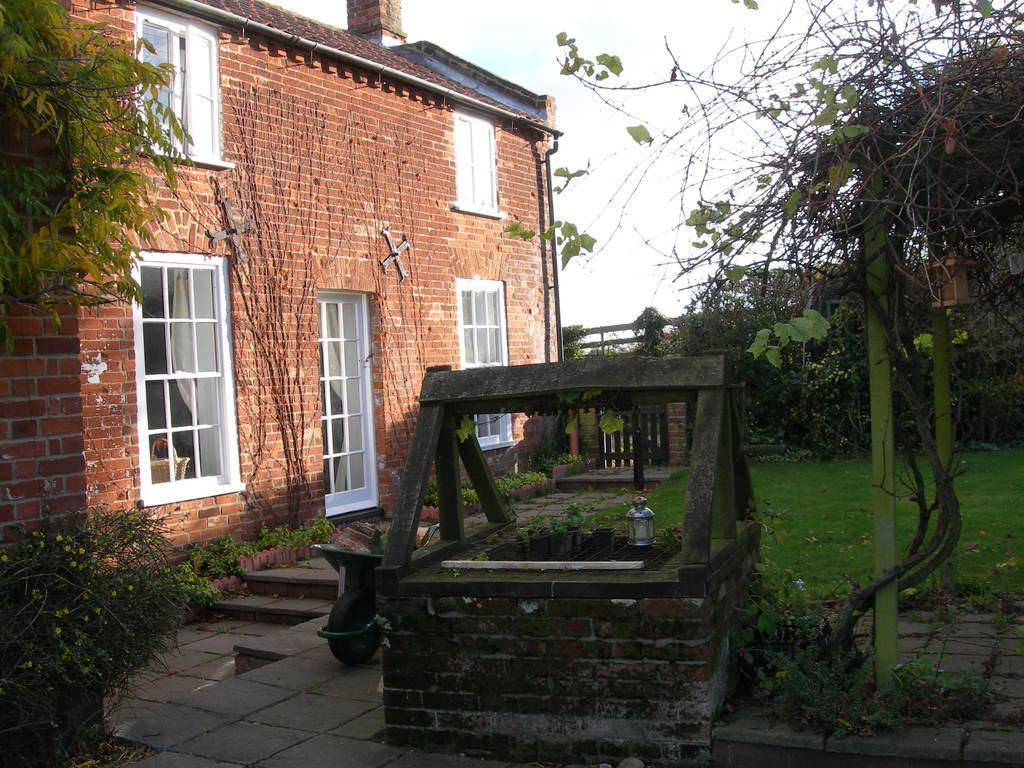Describe this image in one or two sentences. In this picture I can see there is a building it has some windows, a well, some plants, trees and the sky is clear. 